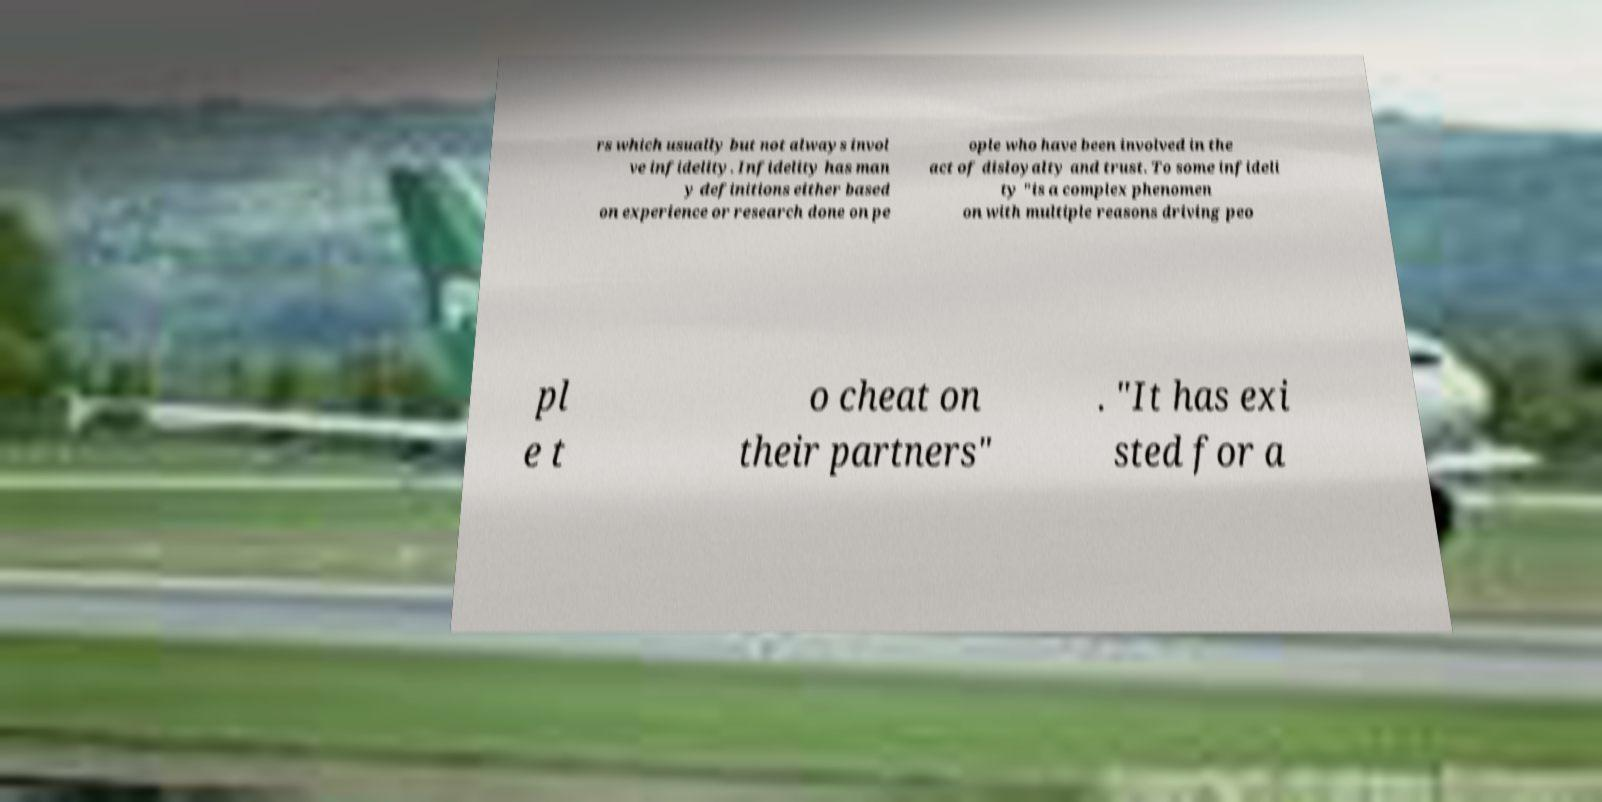Could you assist in decoding the text presented in this image and type it out clearly? rs which usually but not always invol ve infidelity. Infidelity has man y definitions either based on experience or research done on pe ople who have been involved in the act of disloyalty and trust. To some infideli ty "is a complex phenomen on with multiple reasons driving peo pl e t o cheat on their partners" . "It has exi sted for a 